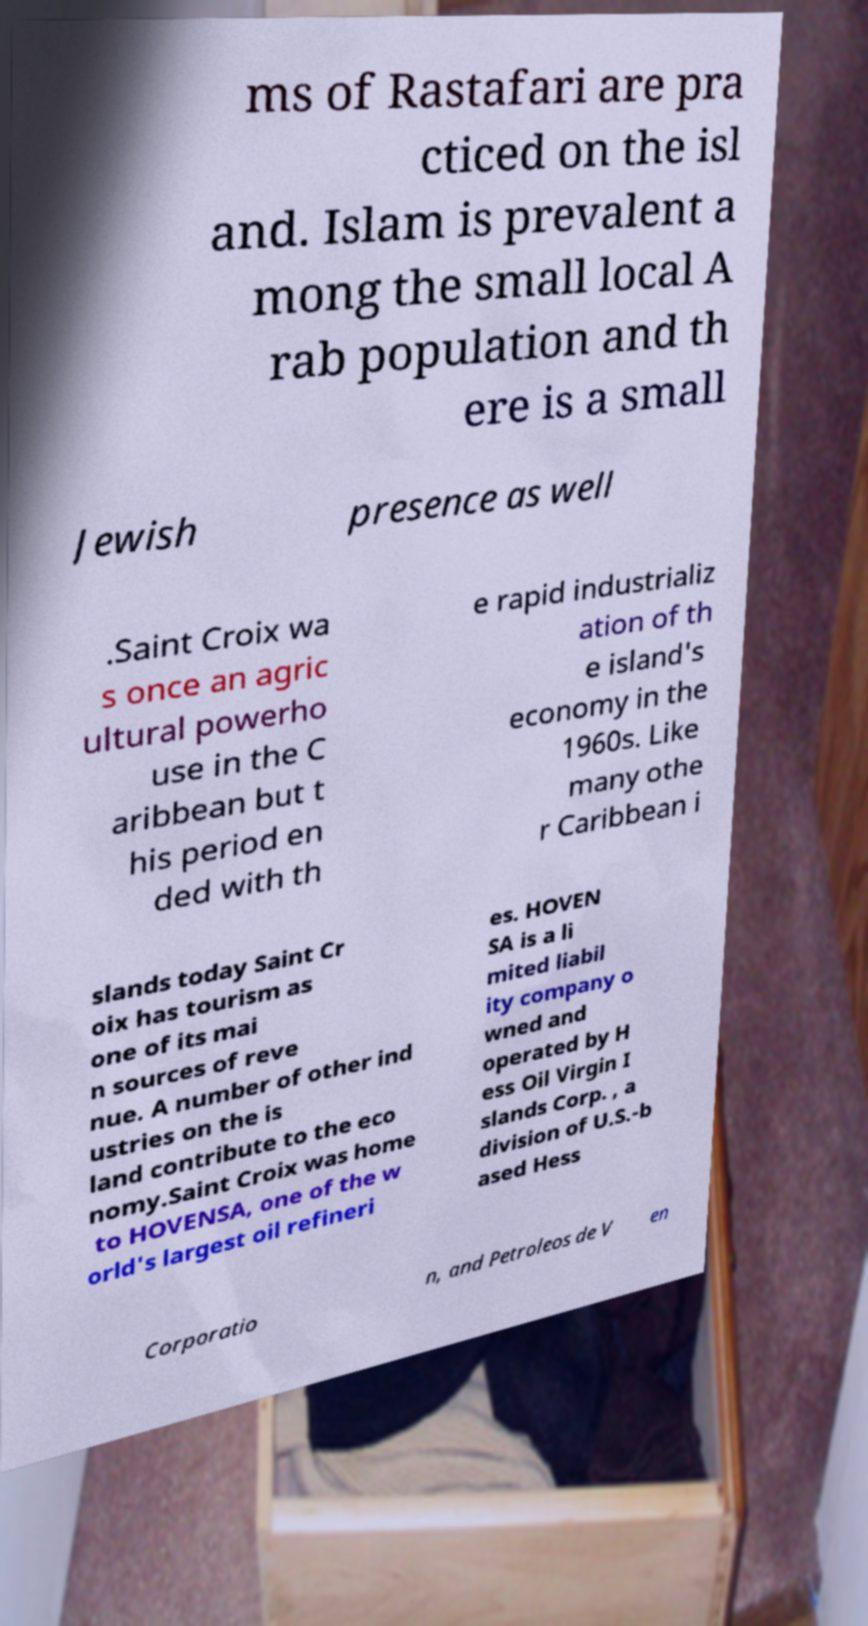Could you assist in decoding the text presented in this image and type it out clearly? ms of Rastafari are pra cticed on the isl and. Islam is prevalent a mong the small local A rab population and th ere is a small Jewish presence as well .Saint Croix wa s once an agric ultural powerho use in the C aribbean but t his period en ded with th e rapid industrializ ation of th e island's economy in the 1960s. Like many othe r Caribbean i slands today Saint Cr oix has tourism as one of its mai n sources of reve nue. A number of other ind ustries on the is land contribute to the eco nomy.Saint Croix was home to HOVENSA, one of the w orld's largest oil refineri es. HOVEN SA is a li mited liabil ity company o wned and operated by H ess Oil Virgin I slands Corp. , a division of U.S.-b ased Hess Corporatio n, and Petroleos de V en 